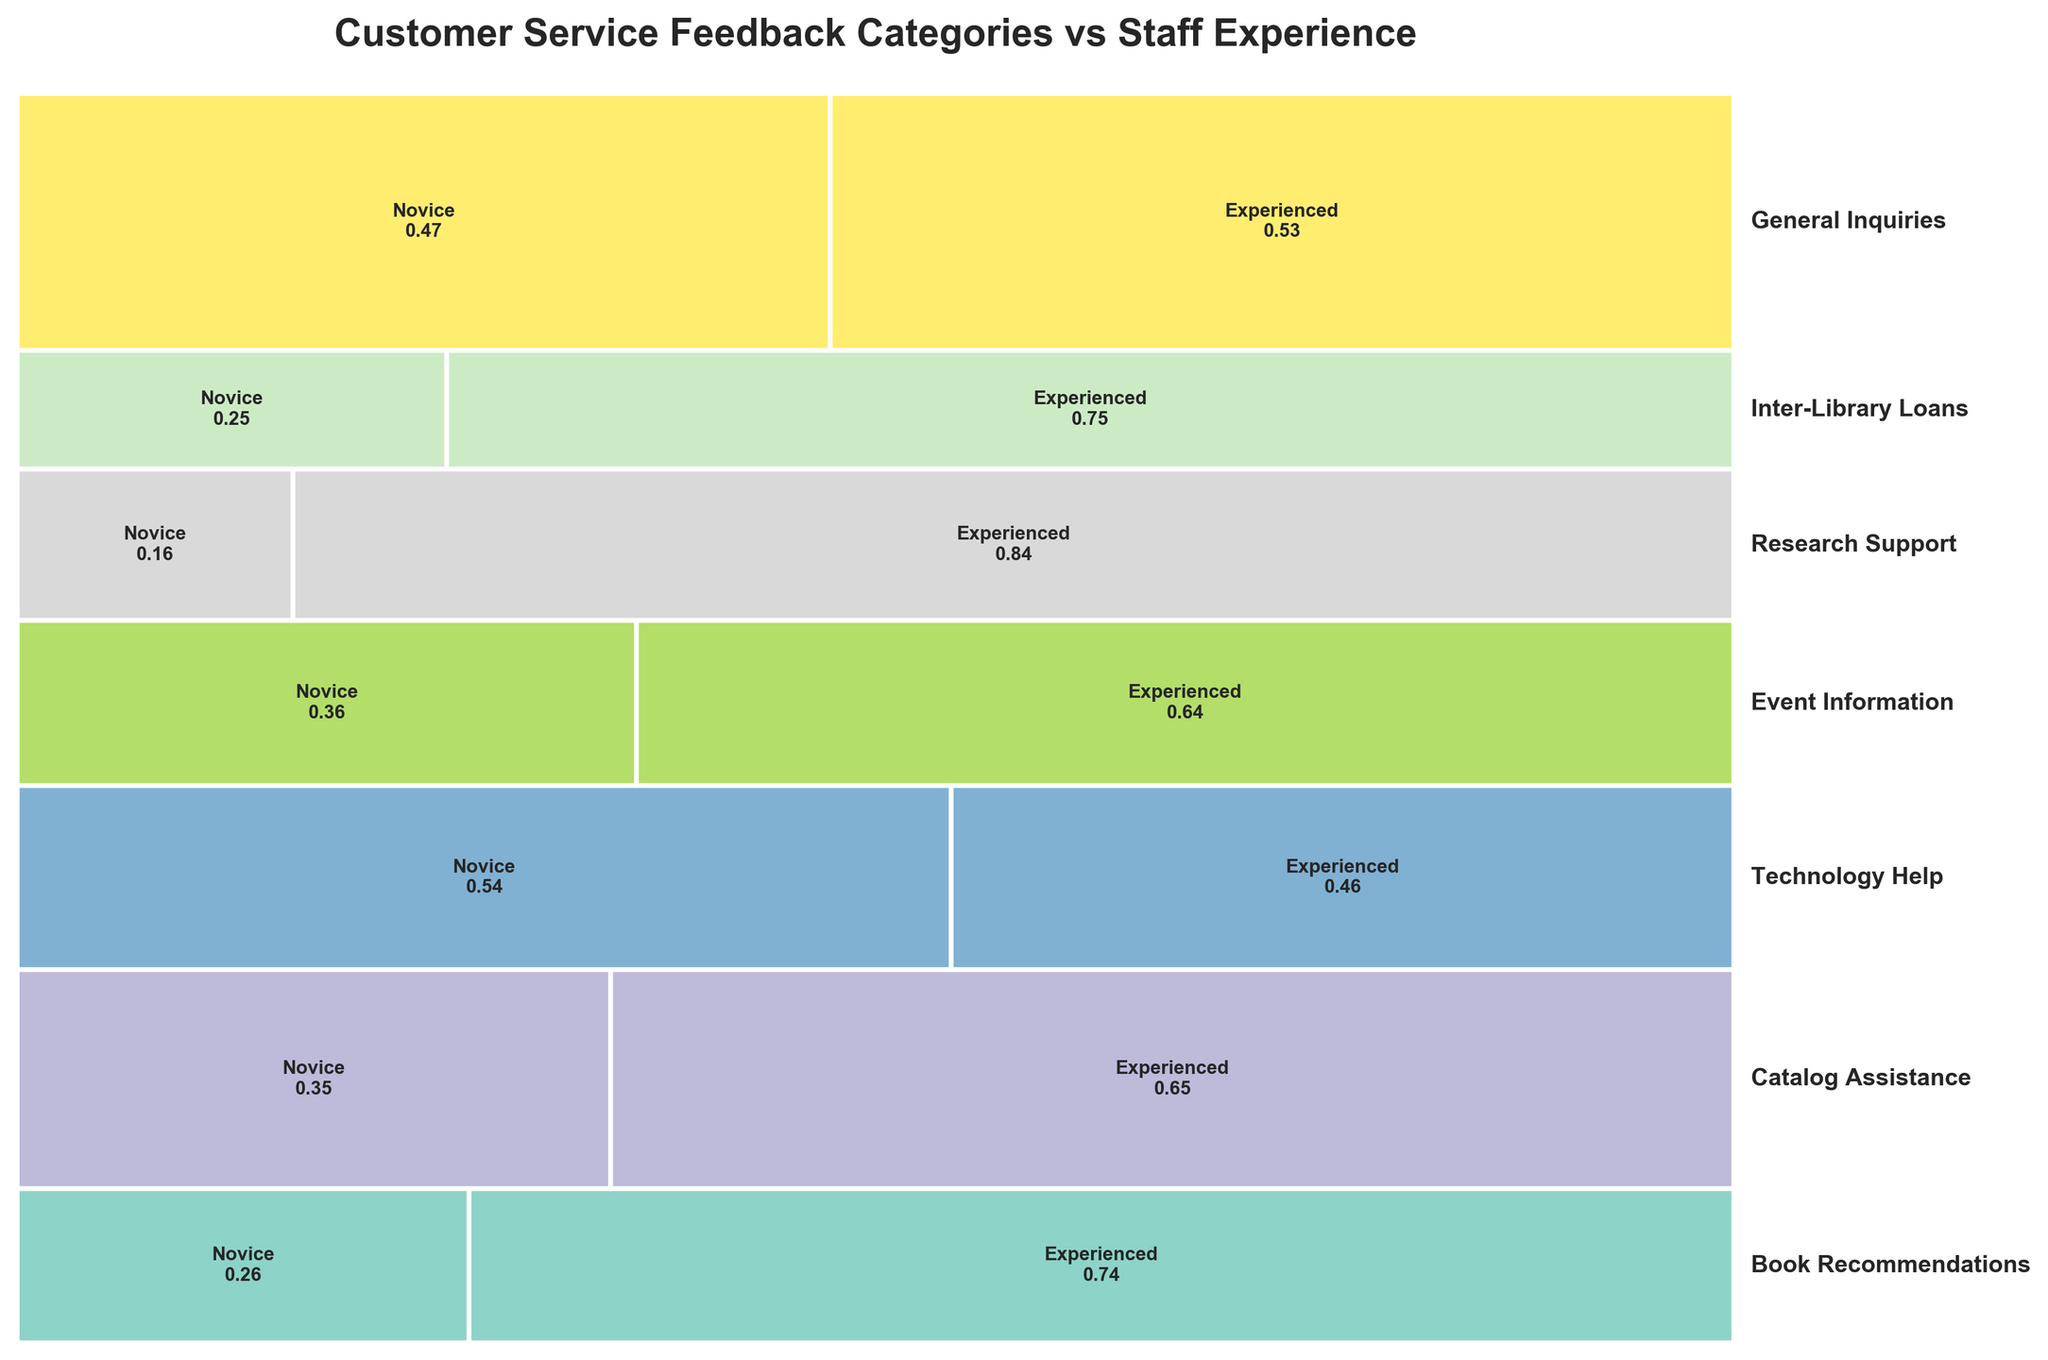How many categories of customer service feedback are shown in the figure? The figure displays various customer service categories, each labeled along the right-hand side of the plot. Counting these labels will give the total number of categories.
Answer: 7 What is the title of the plot? The title is usually placed at the top of the figure and provides a summary of what the plot shows.
Answer: Customer Service Feedback Categories vs Staff Experience Which staff experience level has a higher proportion for "Book Recommendations"? The proportions for each experience level within the category "Book Recommendations" can be compared by looking at the widths of the rectangles representing Novice and Experienced.
Answer: Experienced For which category do Novice staff have the highest proportion? Compare the widths of the rectangles representing Novice staff across all categories. The widest rectangle will indicate the category with the highest proportion for Novice staff.
Answer: General Inquiries Which customer service category has the smallest total frequency? The total frequency for each category corresponds to the height of the bar. The shortest height represents the smallest total frequency.
Answer: Research Support How do the frequencies for "Technology Help" compare between Novice and Experienced staff? The widths of the rectangles representing Novice and Experienced staff within "Technology Help" need to be compared.
Answer: Novice higher, Experienced lower Which category shows a near-equal distribution between Novice and Experienced staff? A near-equal distribution would show two rectangles of approximately equal width within a category.
Answer: Technology Help What's the combined proportion of Novice and Experienced staff in the "Catalog Assistance" category? For a category like "Catalog Assistance," sum the two proportions that represent Novice and Experienced staff. Since they must sum to 1 by definition, this acts as a sanity check.
Answer: 100% Is there a category where Experienced staff handle all the feedback? Check if any customer service category has a rectangle for Novice staff with a width of zero, indicating Experienced staff handle all feedback.
Answer: No Which experience level handles more feedback for "Event Information"? Compare the width of the rectangles representing each experience level for the "Event Information" category. The wider rectangle indicates which experience level handles more feedback.
Answer: Experienced 